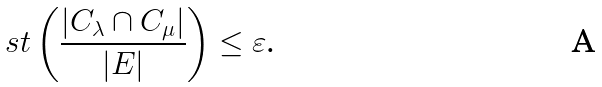Convert formula to latex. <formula><loc_0><loc_0><loc_500><loc_500>s t \left ( \frac { | C _ { \lambda } \cap C _ { \mu } | } { | E | } \right ) \leq \varepsilon \text {.}</formula> 